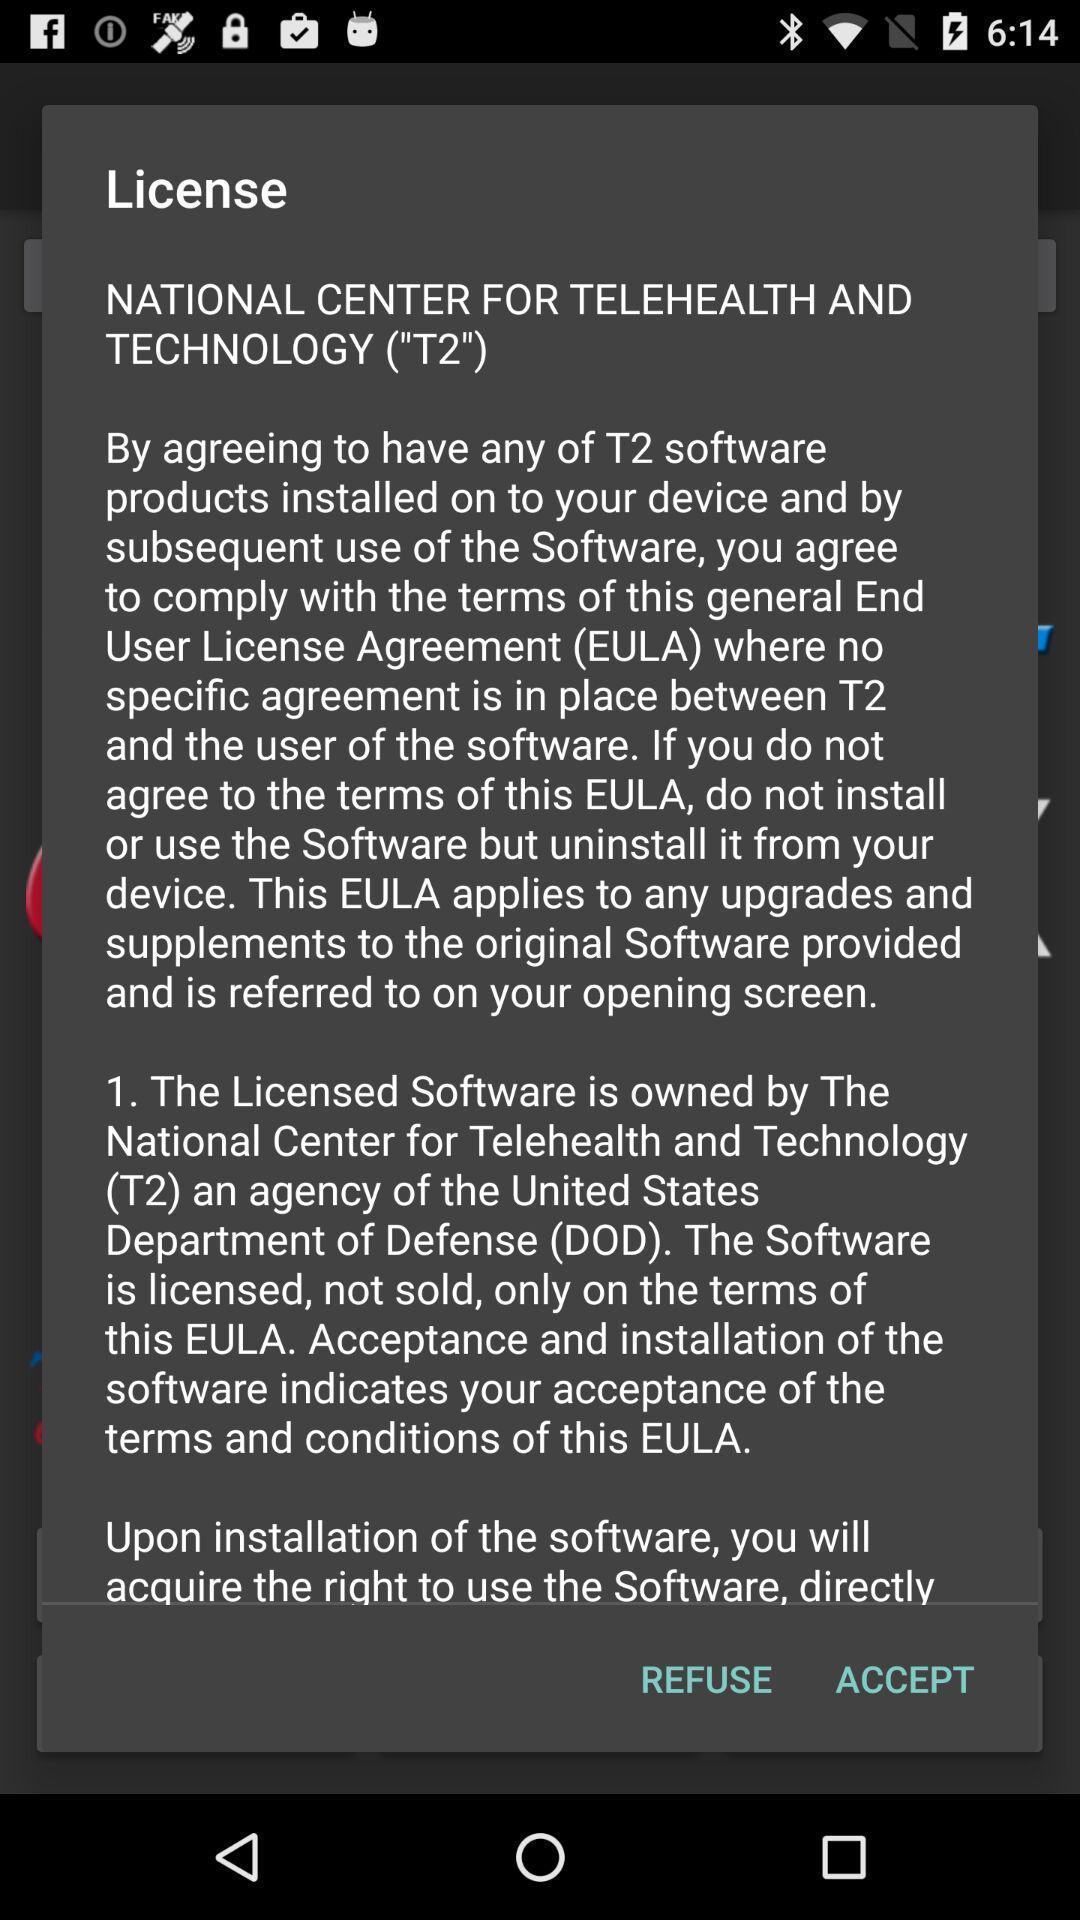Please provide a description for this image. Screen asking to access a pop up. 